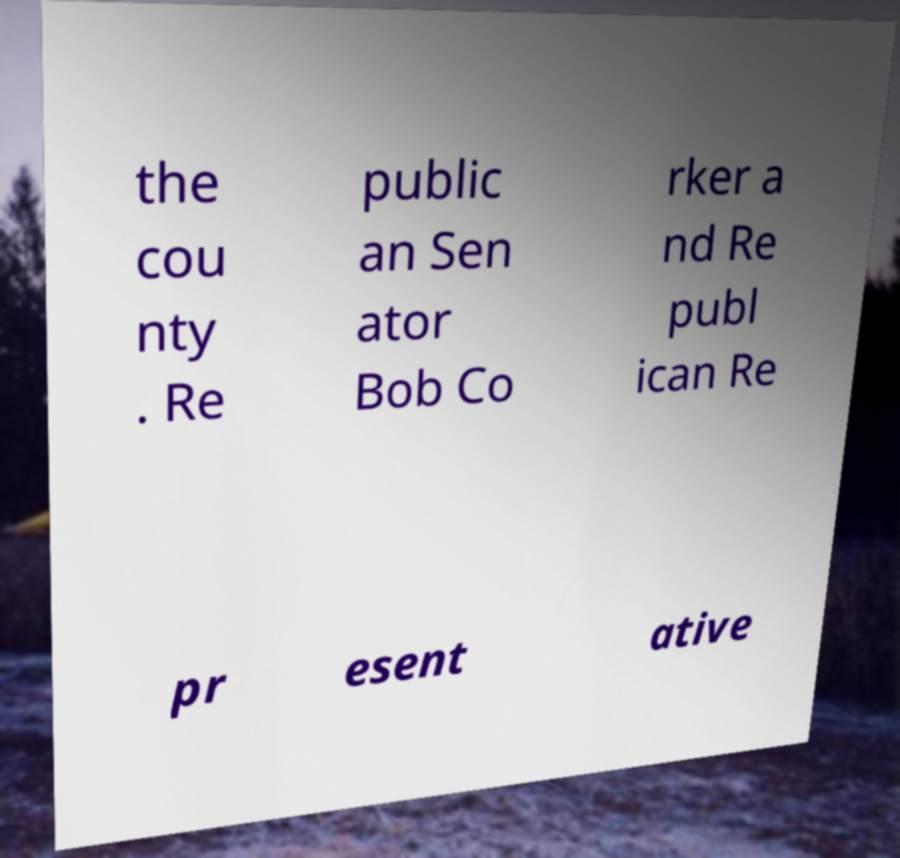I need the written content from this picture converted into text. Can you do that? the cou nty . Re public an Sen ator Bob Co rker a nd Re publ ican Re pr esent ative 